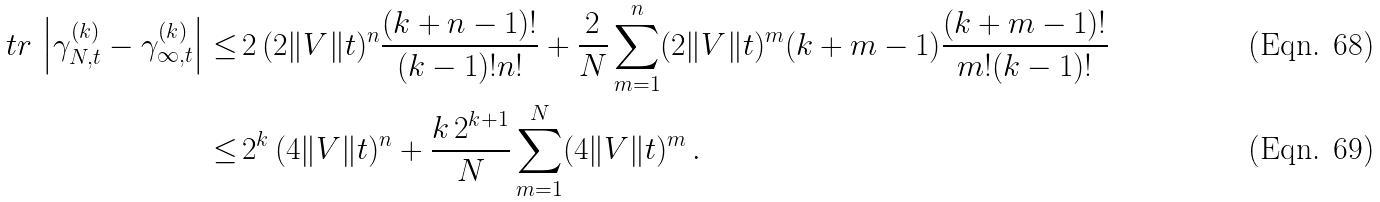Convert formula to latex. <formula><loc_0><loc_0><loc_500><loc_500>\ t r \, \left | \gamma ^ { ( k ) } _ { N , t } - \gamma ^ { ( k ) } _ { \infty , t } \right | \leq \, & 2 \, ( 2 \| V \| t ) ^ { n } \frac { ( k + n - 1 ) ! } { ( k - 1 ) ! n ! } + \frac { 2 } { N } \sum _ { m = 1 } ^ { n } ( 2 \| V \| t ) ^ { m } ( k + m - 1 ) \frac { ( k + m - 1 ) ! } { m ! ( k - 1 ) ! } \\ \leq \, & 2 ^ { k } \, ( 4 \| V \| t ) ^ { n } + \frac { k \, 2 ^ { k + 1 } } { N } \sum _ { m = 1 } ^ { N } ( 4 \| V \| t ) ^ { m } \, .</formula> 